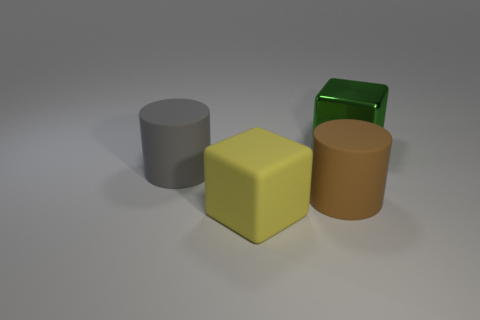Can you describe the texture of the objects in the image? Certainly! The objects appear to have different textures. The gray cylinder and the brown object have a matte, non-reflective surface suggesting a rough or soft texture. In contrast, the yellow cube and green object have smooth, reflective surfaces indicating a slick or glossy texture. 